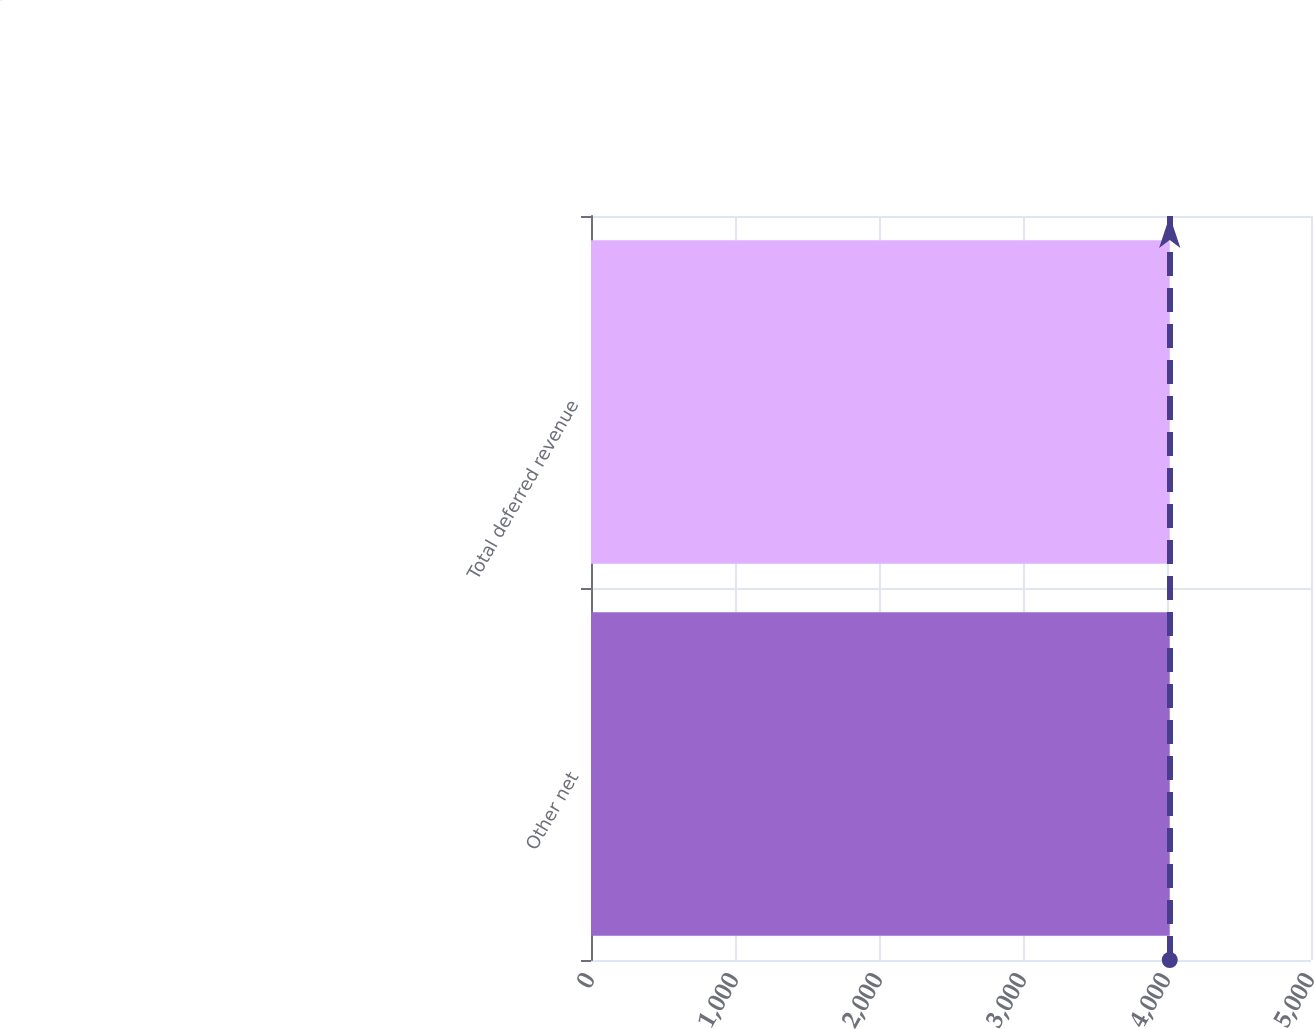Convert chart to OTSL. <chart><loc_0><loc_0><loc_500><loc_500><bar_chart><fcel>Other net<fcel>Total deferred revenue<nl><fcel>4019<fcel>4019.1<nl></chart> 